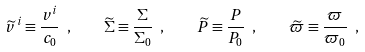<formula> <loc_0><loc_0><loc_500><loc_500>\widetilde { v } ^ { \, i } \equiv \frac { v ^ { i } } { c _ { 0 } } \ , \quad { \widetilde { \Sigma } } \equiv \frac { \Sigma } { \Sigma _ { 0 } } \ , \quad { \widetilde { P } } \equiv \frac { P } { P _ { 0 } } \ , \quad { \widetilde { \varpi } } \equiv \frac { \varpi } { \varpi _ { 0 } } \ ,</formula> 